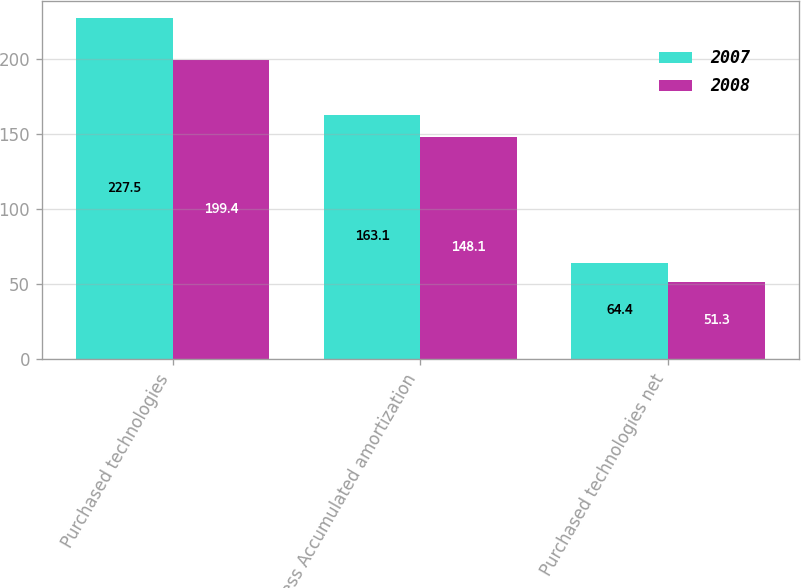<chart> <loc_0><loc_0><loc_500><loc_500><stacked_bar_chart><ecel><fcel>Purchased technologies<fcel>Less Accumulated amortization<fcel>Purchased technologies net<nl><fcel>2007<fcel>227.5<fcel>163.1<fcel>64.4<nl><fcel>2008<fcel>199.4<fcel>148.1<fcel>51.3<nl></chart> 